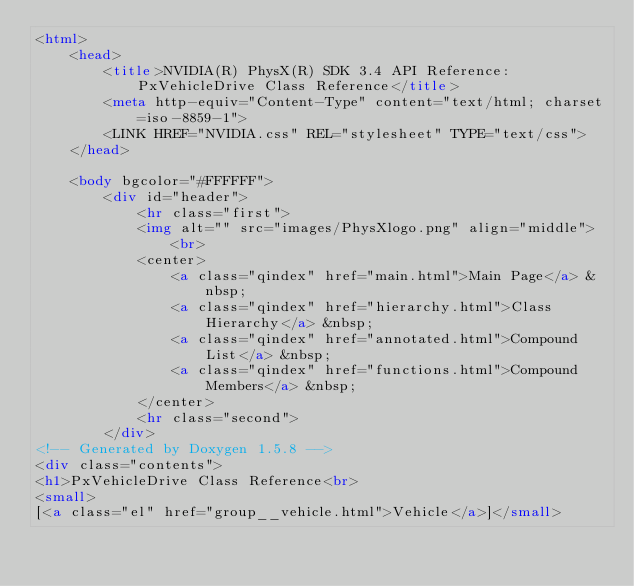<code> <loc_0><loc_0><loc_500><loc_500><_HTML_><html>
	<head>
		<title>NVIDIA(R) PhysX(R) SDK 3.4 API Reference: PxVehicleDrive Class Reference</title>
		<meta http-equiv="Content-Type" content="text/html; charset=iso-8859-1">
		<LINK HREF="NVIDIA.css" REL="stylesheet" TYPE="text/css">
	</head>

	<body bgcolor="#FFFFFF">
		<div id="header">
			<hr class="first">
			<img alt="" src="images/PhysXlogo.png" align="middle"> <br>
			<center>
				<a class="qindex" href="main.html">Main Page</a> &nbsp; 
				<a class="qindex" href="hierarchy.html">Class Hierarchy</a> &nbsp; 
				<a class="qindex" href="annotated.html">Compound List</a> &nbsp; 
				<a class="qindex" href="functions.html">Compound Members</a> &nbsp;  
			</center>
			<hr class="second">
		</div>
<!-- Generated by Doxygen 1.5.8 -->
<div class="contents">
<h1>PxVehicleDrive Class Reference<br>
<small>
[<a class="el" href="group__vehicle.html">Vehicle</a>]</small></code> 